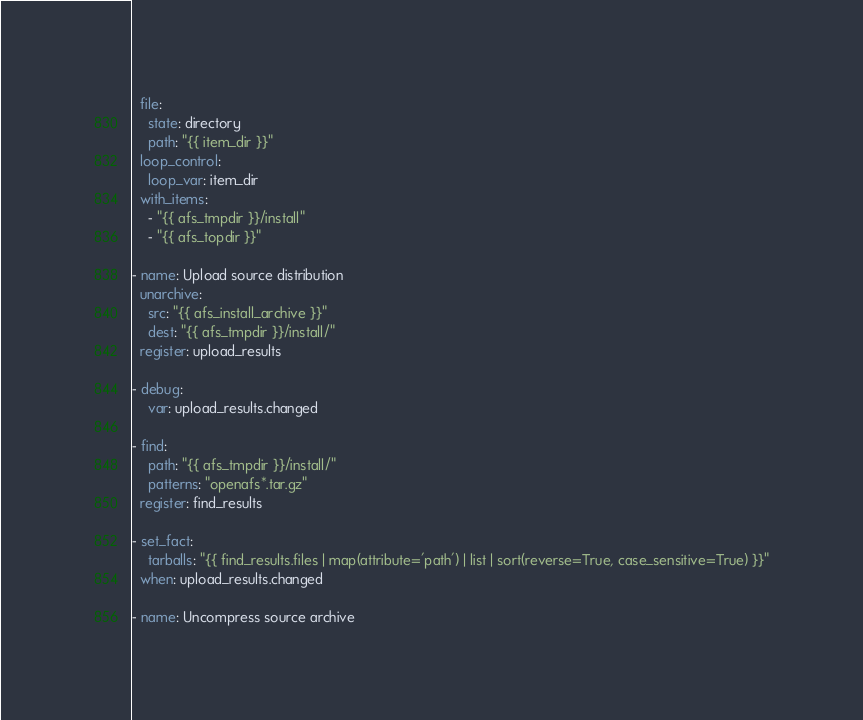Convert code to text. <code><loc_0><loc_0><loc_500><loc_500><_YAML_>  file:
    state: directory
    path: "{{ item_dir }}"
  loop_control:
    loop_var: item_dir
  with_items:
    - "{{ afs_tmpdir }}/install"
    - "{{ afs_topdir }}"

- name: Upload source distribution
  unarchive:
    src: "{{ afs_install_archive }}"
    dest: "{{ afs_tmpdir }}/install/"
  register: upload_results

- debug:
    var: upload_results.changed

- find:
    path: "{{ afs_tmpdir }}/install/"
    patterns: "openafs*.tar.gz"
  register: find_results

- set_fact:
    tarballs: "{{ find_results.files | map(attribute='path') | list | sort(reverse=True, case_sensitive=True) }}"
  when: upload_results.changed

- name: Uncompress source archive</code> 